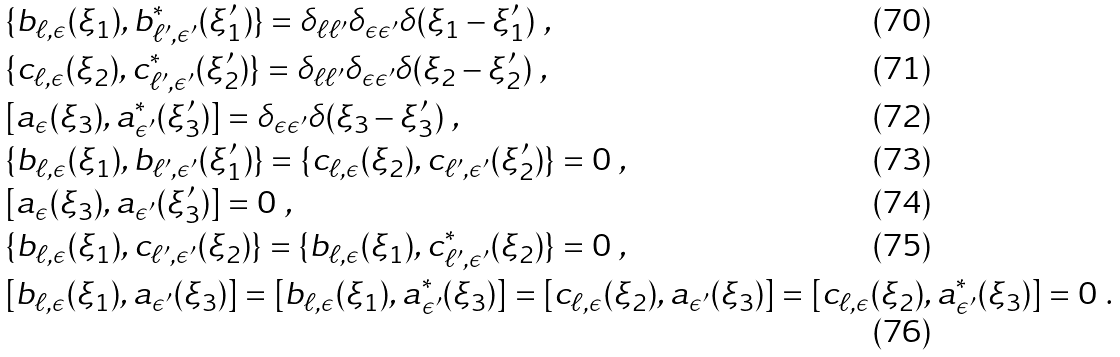<formula> <loc_0><loc_0><loc_500><loc_500>& \{ b _ { \ell , \epsilon } ( \xi _ { 1 } ) , b ^ { * } _ { \ell ^ { \prime } , \epsilon ^ { \prime } } ( \xi _ { 1 } ^ { \prime } ) \} = \delta _ { \ell \ell ^ { \prime } } \delta _ { \epsilon \epsilon ^ { \prime } } \delta ( \xi _ { 1 } - \xi _ { 1 } ^ { \prime } ) \ , \\ & \{ c _ { \ell , \epsilon } ( \xi _ { 2 } ) , c ^ { * } _ { \ell ^ { \prime } , \epsilon ^ { \prime } } ( \xi _ { 2 } ^ { \prime } ) \} = \delta _ { \ell \ell ^ { \prime } } \delta _ { \epsilon \epsilon ^ { \prime } } \delta ( \xi _ { 2 } - \xi _ { 2 } ^ { \prime } ) \ , \\ & [ a _ { \epsilon } ( \xi _ { 3 } ) , a ^ { * } _ { \epsilon ^ { \prime } } ( \xi _ { 3 } ^ { \prime } ) ] = \delta _ { \epsilon \epsilon ^ { \prime } } \delta ( \xi _ { 3 } - \xi _ { 3 } ^ { \prime } ) \ , \\ & \{ b _ { \ell , \epsilon } ( \xi _ { 1 } ) , b _ { \ell ^ { \prime } , \epsilon ^ { \prime } } ( \xi _ { 1 } ^ { \prime } ) \} = \{ c _ { \ell , \epsilon } ( \xi _ { 2 } ) , c _ { \ell ^ { \prime } , \epsilon ^ { \prime } } ( \xi _ { 2 } ^ { \prime } ) \} = 0 \ , \\ & [ a _ { \epsilon } ( \xi _ { 3 } ) , a _ { \epsilon ^ { \prime } } ( \xi _ { 3 } ^ { \prime } ) ] = 0 \ , \\ & \{ b _ { \ell , \epsilon } ( \xi _ { 1 } ) , c _ { \ell ^ { \prime } , \epsilon ^ { \prime } } ( \xi _ { 2 } ) \} = \{ b _ { \ell , \epsilon } ( \xi _ { 1 } ) , c ^ { * } _ { \ell ^ { \prime } , \epsilon ^ { \prime } } ( \xi _ { 2 } ) \} = 0 \ , \\ & [ b _ { \ell , \epsilon } ( \xi _ { 1 } ) , a _ { \epsilon ^ { \prime } } ( \xi _ { 3 } ) ] = [ b _ { \ell , \epsilon } ( \xi _ { 1 } ) , a ^ { * } _ { \epsilon ^ { \prime } } ( \xi _ { 3 } ) ] = [ c _ { \ell , \epsilon } ( \xi _ { 2 } ) , a _ { \epsilon ^ { \prime } } ( \xi _ { 3 } ) ] = [ c _ { \ell , \epsilon } ( \xi _ { 2 } ) , a ^ { * } _ { \epsilon ^ { \prime } } ( \xi _ { 3 } ) ] = 0 \ .</formula> 